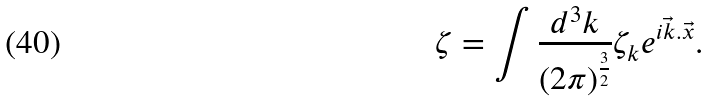<formula> <loc_0><loc_0><loc_500><loc_500>\zeta = \int \frac { d ^ { 3 } k } { ( 2 \pi ) ^ { \frac { 3 } { 2 } } } \zeta _ { k } e ^ { i \vec { k } . \vec { x } } .</formula> 